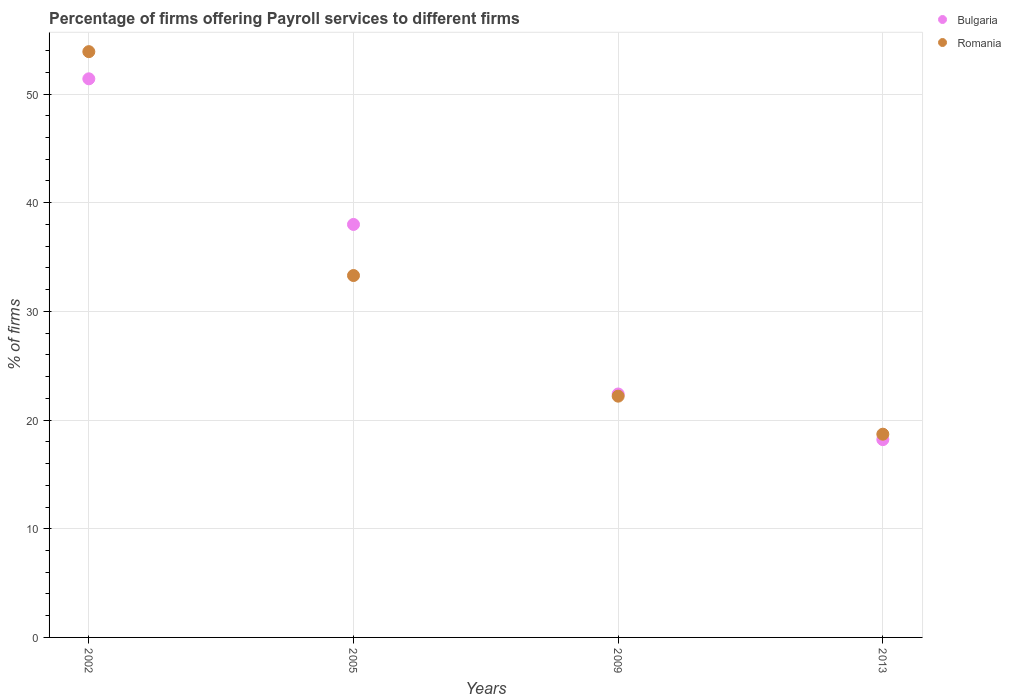How many different coloured dotlines are there?
Provide a short and direct response. 2. Across all years, what is the maximum percentage of firms offering payroll services in Bulgaria?
Your answer should be compact. 51.4. In which year was the percentage of firms offering payroll services in Bulgaria minimum?
Provide a short and direct response. 2013. What is the total percentage of firms offering payroll services in Bulgaria in the graph?
Offer a very short reply. 130. What is the difference between the percentage of firms offering payroll services in Romania in 2005 and that in 2009?
Offer a very short reply. 11.1. What is the difference between the percentage of firms offering payroll services in Bulgaria in 2013 and the percentage of firms offering payroll services in Romania in 2005?
Ensure brevity in your answer.  -15.1. What is the average percentage of firms offering payroll services in Romania per year?
Give a very brief answer. 32.02. In the year 2009, what is the difference between the percentage of firms offering payroll services in Bulgaria and percentage of firms offering payroll services in Romania?
Give a very brief answer. 0.2. What is the ratio of the percentage of firms offering payroll services in Bulgaria in 2002 to that in 2009?
Ensure brevity in your answer.  2.29. Is the difference between the percentage of firms offering payroll services in Bulgaria in 2005 and 2013 greater than the difference between the percentage of firms offering payroll services in Romania in 2005 and 2013?
Make the answer very short. Yes. What is the difference between the highest and the second highest percentage of firms offering payroll services in Bulgaria?
Offer a very short reply. 13.4. What is the difference between the highest and the lowest percentage of firms offering payroll services in Romania?
Your response must be concise. 35.2. Is the sum of the percentage of firms offering payroll services in Romania in 2002 and 2005 greater than the maximum percentage of firms offering payroll services in Bulgaria across all years?
Your response must be concise. Yes. Does the percentage of firms offering payroll services in Romania monotonically increase over the years?
Your answer should be very brief. No. Is the percentage of firms offering payroll services in Romania strictly less than the percentage of firms offering payroll services in Bulgaria over the years?
Give a very brief answer. No. How many dotlines are there?
Offer a terse response. 2. What is the difference between two consecutive major ticks on the Y-axis?
Your answer should be compact. 10. Are the values on the major ticks of Y-axis written in scientific E-notation?
Keep it short and to the point. No. Where does the legend appear in the graph?
Your response must be concise. Top right. What is the title of the graph?
Keep it short and to the point. Percentage of firms offering Payroll services to different firms. What is the label or title of the Y-axis?
Provide a short and direct response. % of firms. What is the % of firms in Bulgaria in 2002?
Ensure brevity in your answer.  51.4. What is the % of firms in Romania in 2002?
Offer a very short reply. 53.9. What is the % of firms of Bulgaria in 2005?
Keep it short and to the point. 38. What is the % of firms of Romania in 2005?
Your answer should be very brief. 33.3. What is the % of firms of Bulgaria in 2009?
Give a very brief answer. 22.4. Across all years, what is the maximum % of firms of Bulgaria?
Your response must be concise. 51.4. Across all years, what is the maximum % of firms of Romania?
Make the answer very short. 53.9. Across all years, what is the minimum % of firms of Romania?
Ensure brevity in your answer.  18.7. What is the total % of firms in Bulgaria in the graph?
Ensure brevity in your answer.  130. What is the total % of firms in Romania in the graph?
Your response must be concise. 128.1. What is the difference between the % of firms in Bulgaria in 2002 and that in 2005?
Offer a very short reply. 13.4. What is the difference between the % of firms of Romania in 2002 and that in 2005?
Make the answer very short. 20.6. What is the difference between the % of firms in Bulgaria in 2002 and that in 2009?
Keep it short and to the point. 29. What is the difference between the % of firms in Romania in 2002 and that in 2009?
Provide a succinct answer. 31.7. What is the difference between the % of firms of Bulgaria in 2002 and that in 2013?
Ensure brevity in your answer.  33.2. What is the difference between the % of firms of Romania in 2002 and that in 2013?
Offer a very short reply. 35.2. What is the difference between the % of firms of Bulgaria in 2005 and that in 2009?
Your response must be concise. 15.6. What is the difference between the % of firms in Bulgaria in 2005 and that in 2013?
Your response must be concise. 19.8. What is the difference between the % of firms of Romania in 2009 and that in 2013?
Your answer should be compact. 3.5. What is the difference between the % of firms of Bulgaria in 2002 and the % of firms of Romania in 2005?
Provide a succinct answer. 18.1. What is the difference between the % of firms of Bulgaria in 2002 and the % of firms of Romania in 2009?
Keep it short and to the point. 29.2. What is the difference between the % of firms of Bulgaria in 2002 and the % of firms of Romania in 2013?
Provide a short and direct response. 32.7. What is the difference between the % of firms of Bulgaria in 2005 and the % of firms of Romania in 2009?
Offer a very short reply. 15.8. What is the difference between the % of firms in Bulgaria in 2005 and the % of firms in Romania in 2013?
Keep it short and to the point. 19.3. What is the difference between the % of firms of Bulgaria in 2009 and the % of firms of Romania in 2013?
Provide a succinct answer. 3.7. What is the average % of firms of Bulgaria per year?
Offer a very short reply. 32.5. What is the average % of firms in Romania per year?
Keep it short and to the point. 32.02. In the year 2002, what is the difference between the % of firms of Bulgaria and % of firms of Romania?
Your answer should be compact. -2.5. In the year 2005, what is the difference between the % of firms in Bulgaria and % of firms in Romania?
Your answer should be compact. 4.7. In the year 2013, what is the difference between the % of firms in Bulgaria and % of firms in Romania?
Your answer should be very brief. -0.5. What is the ratio of the % of firms of Bulgaria in 2002 to that in 2005?
Provide a short and direct response. 1.35. What is the ratio of the % of firms in Romania in 2002 to that in 2005?
Provide a succinct answer. 1.62. What is the ratio of the % of firms of Bulgaria in 2002 to that in 2009?
Your answer should be very brief. 2.29. What is the ratio of the % of firms of Romania in 2002 to that in 2009?
Give a very brief answer. 2.43. What is the ratio of the % of firms in Bulgaria in 2002 to that in 2013?
Ensure brevity in your answer.  2.82. What is the ratio of the % of firms of Romania in 2002 to that in 2013?
Provide a succinct answer. 2.88. What is the ratio of the % of firms in Bulgaria in 2005 to that in 2009?
Give a very brief answer. 1.7. What is the ratio of the % of firms in Romania in 2005 to that in 2009?
Provide a short and direct response. 1.5. What is the ratio of the % of firms in Bulgaria in 2005 to that in 2013?
Ensure brevity in your answer.  2.09. What is the ratio of the % of firms of Romania in 2005 to that in 2013?
Make the answer very short. 1.78. What is the ratio of the % of firms of Bulgaria in 2009 to that in 2013?
Your response must be concise. 1.23. What is the ratio of the % of firms in Romania in 2009 to that in 2013?
Make the answer very short. 1.19. What is the difference between the highest and the second highest % of firms in Bulgaria?
Your answer should be very brief. 13.4. What is the difference between the highest and the second highest % of firms in Romania?
Your answer should be compact. 20.6. What is the difference between the highest and the lowest % of firms in Bulgaria?
Give a very brief answer. 33.2. What is the difference between the highest and the lowest % of firms in Romania?
Your response must be concise. 35.2. 